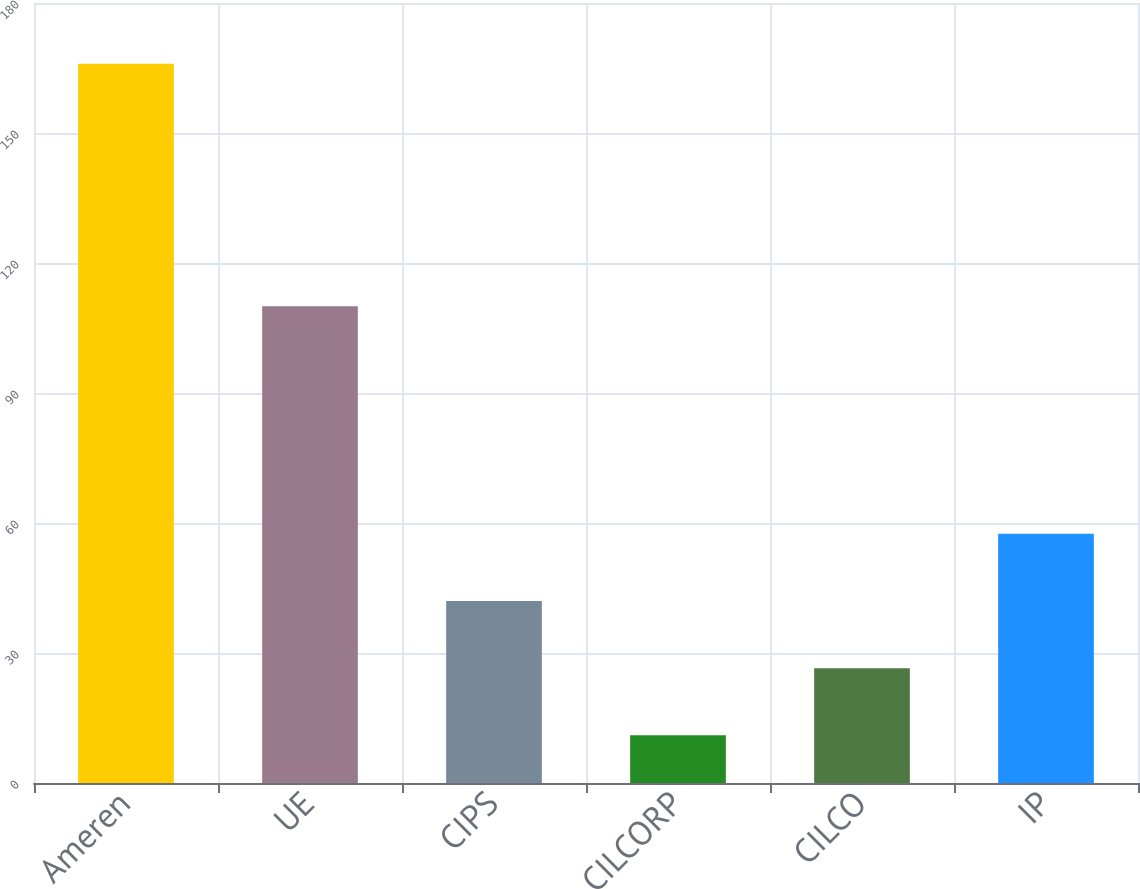Convert chart. <chart><loc_0><loc_0><loc_500><loc_500><bar_chart><fcel>Ameren<fcel>UE<fcel>CIPS<fcel>CILCORP<fcel>CILCO<fcel>IP<nl><fcel>166<fcel>110<fcel>42<fcel>11<fcel>26.5<fcel>57.5<nl></chart> 